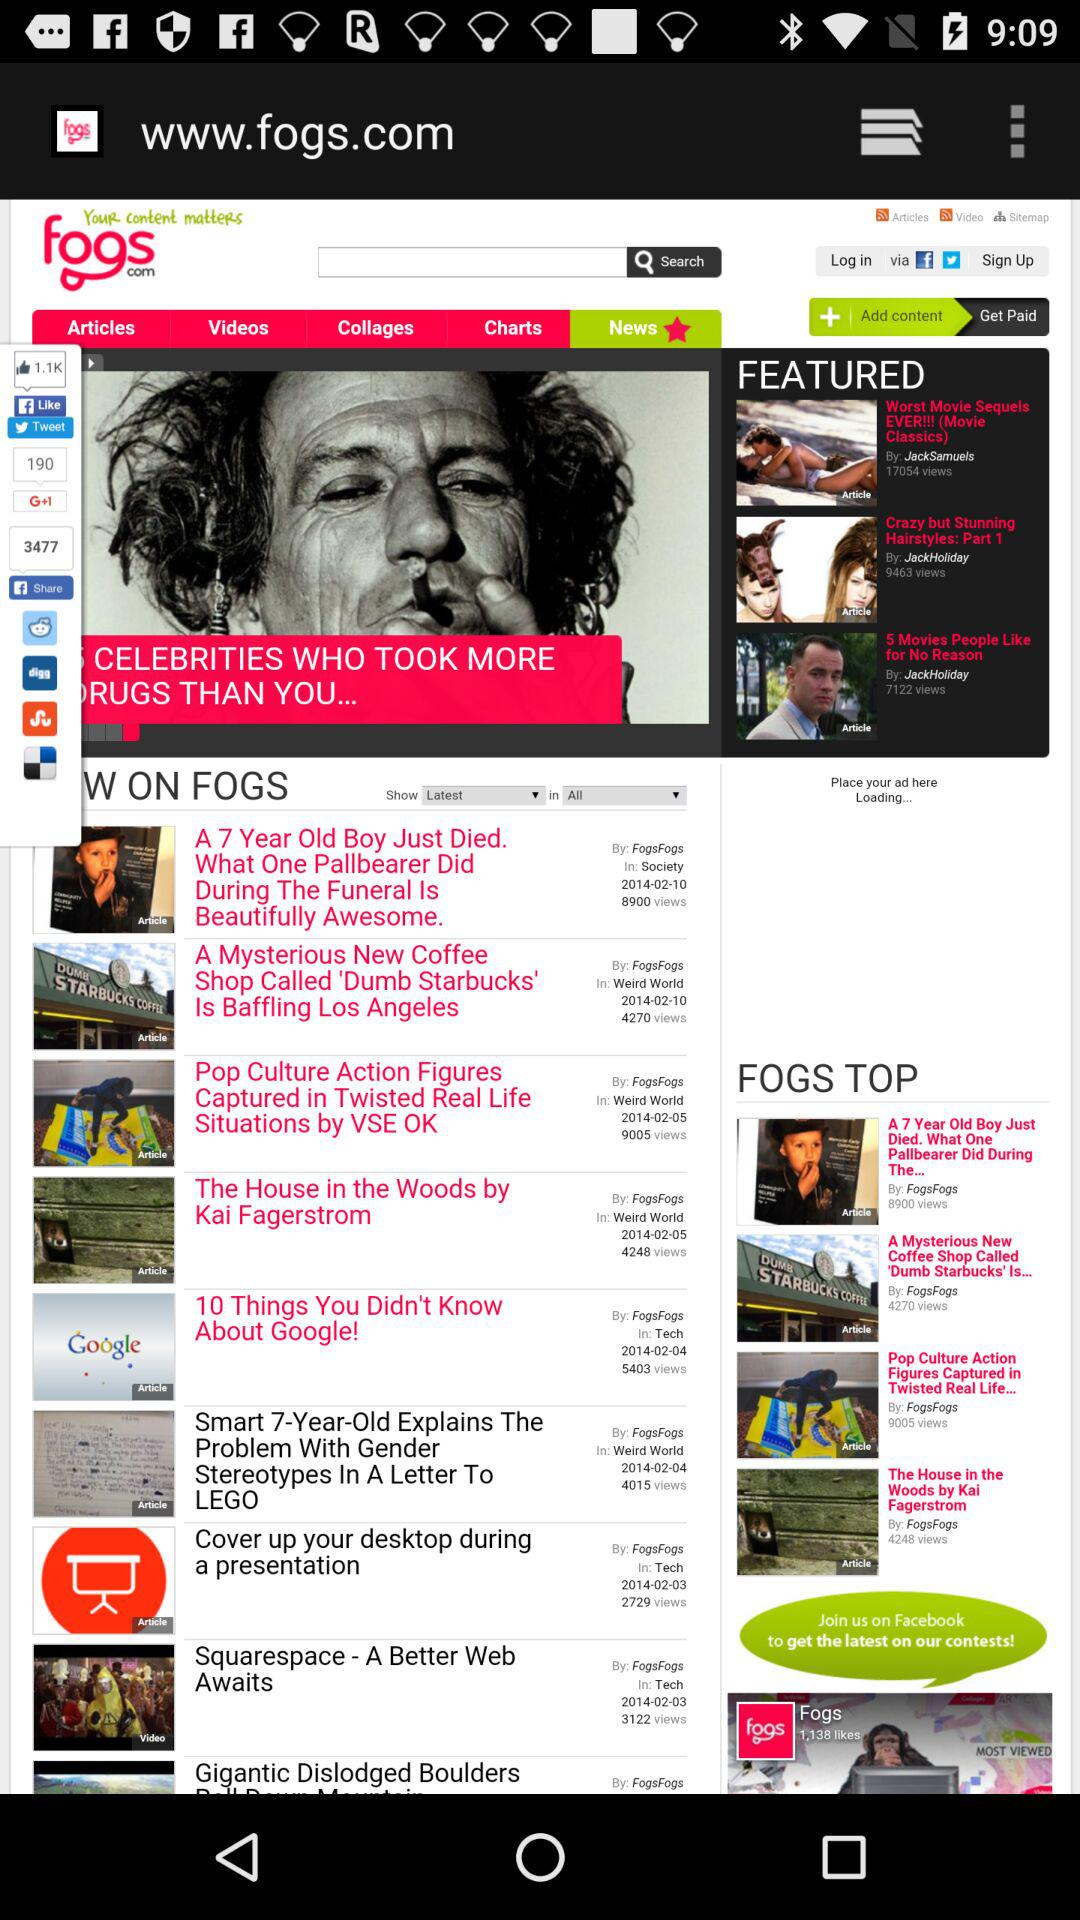Through what application can we log in? We can log in via Facebook and Twitter. 